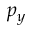<formula> <loc_0><loc_0><loc_500><loc_500>p _ { y }</formula> 